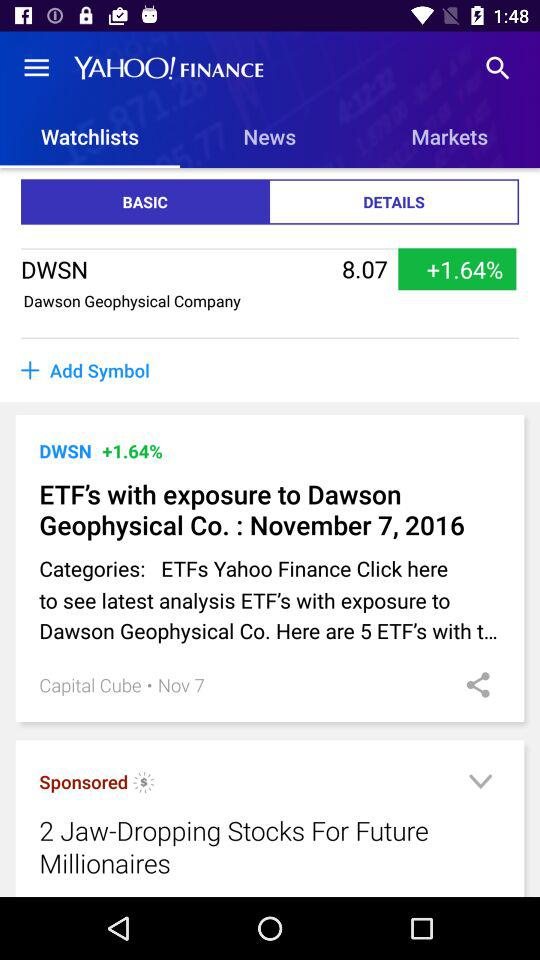What option has been chosen? The option is Basic. 